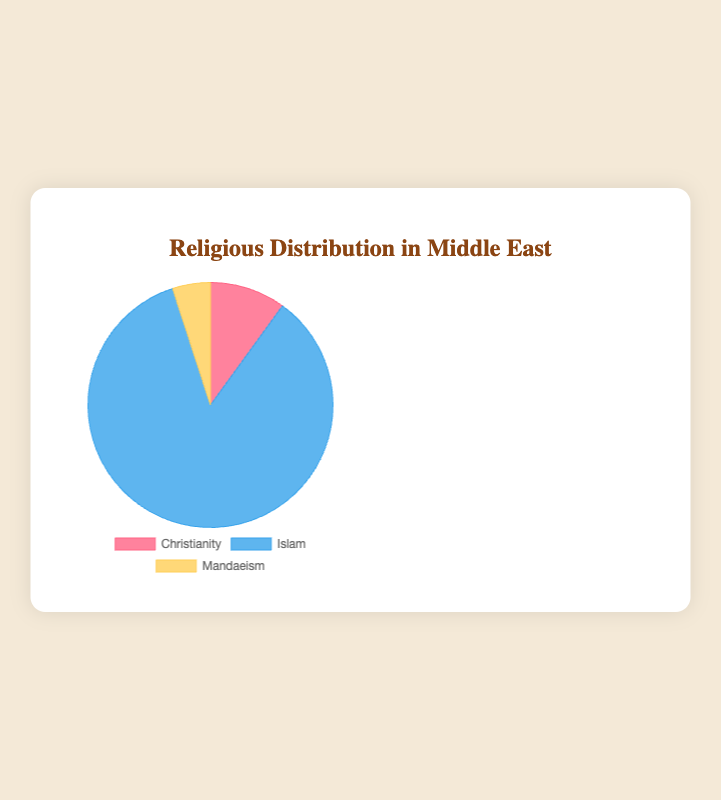Which religious affiliation is the most prevalent in the Middle East according to the pie chart? The largest portion in the pie chart represents Islam, indicating it's the most prevalent.
Answer: Islam What percentage of the population in the Middle East follows Christianity and Mandaeism combined? The chart shows Christianity at 10% and Mandaeism at 5%. Combined, this is 10% + 5% = 15%.
Answer: 15% How does the proportion of Christianity compare to Mandaeism in the Middle East? The pie chart shows that Christianity is twice as much as Mandaeism, with Christianity at 10% and Mandaeism at 5%.
Answer: Christianity is twice as much as Mandaeism Is the proportion of people who follow Islam greater or smaller than the sum of those who follow Christianity and Mandaeism in the Middle East? Islam is 85%, and the sum of Christianity and Mandaeism is 15%. Since 85% > 15%, Islam is greater.
Answer: Greater What is the difference in percentage points between those who follow Islam and those who follow Christianity in the Middle East? Islam is at 85% while Christianity is at 10%. The difference is 85% - 10% = 75%.
Answer: 75% How much larger is the segment representing Islam compared to the segment representing Mandaeism on the pie chart? Islam is 85%, and Mandaeism is 5%. The difference is 85% - 5% = 80%.
Answer: 80% Which color in the pie chart represents Christianity? The pie chart uses red to represent Christianity.
Answer: Red If you look at the segments visually, is the segment for Mandaeism the smallest, the largest, or somewhere in between compared to the other religions in the Middle East? The pie chart shows that the Mandaeism segment is the smallest at 5%, compared to Christianity (10%) and Islam (85%).
Answer: The smallest Among the three religious groups shown, which two have the same percentage representation? The chart shows that Christianity is 10% and Mandaeism is 5%, so they do not match. Thus, none of the groups have the same percentage.
Answer: None 